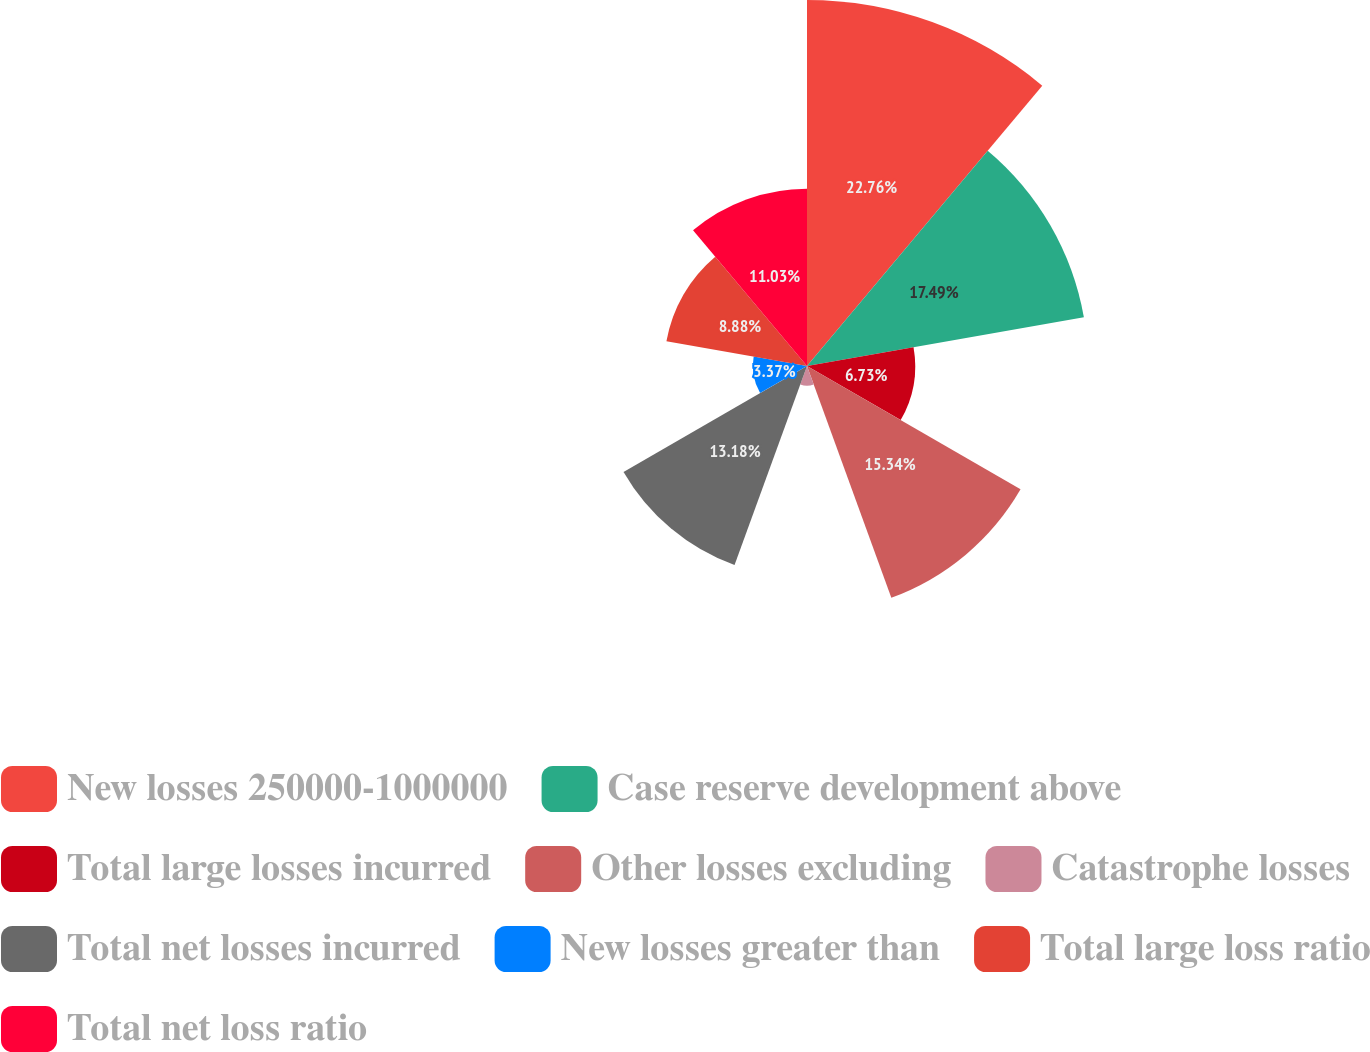Convert chart to OTSL. <chart><loc_0><loc_0><loc_500><loc_500><pie_chart><fcel>New losses 250000-1000000<fcel>Case reserve development above<fcel>Total large losses incurred<fcel>Other losses excluding<fcel>Catastrophe losses<fcel>Total net losses incurred<fcel>New losses greater than<fcel>Total large loss ratio<fcel>Total net loss ratio<nl><fcel>22.77%<fcel>17.49%<fcel>6.73%<fcel>15.34%<fcel>1.22%<fcel>13.18%<fcel>3.37%<fcel>8.88%<fcel>11.03%<nl></chart> 